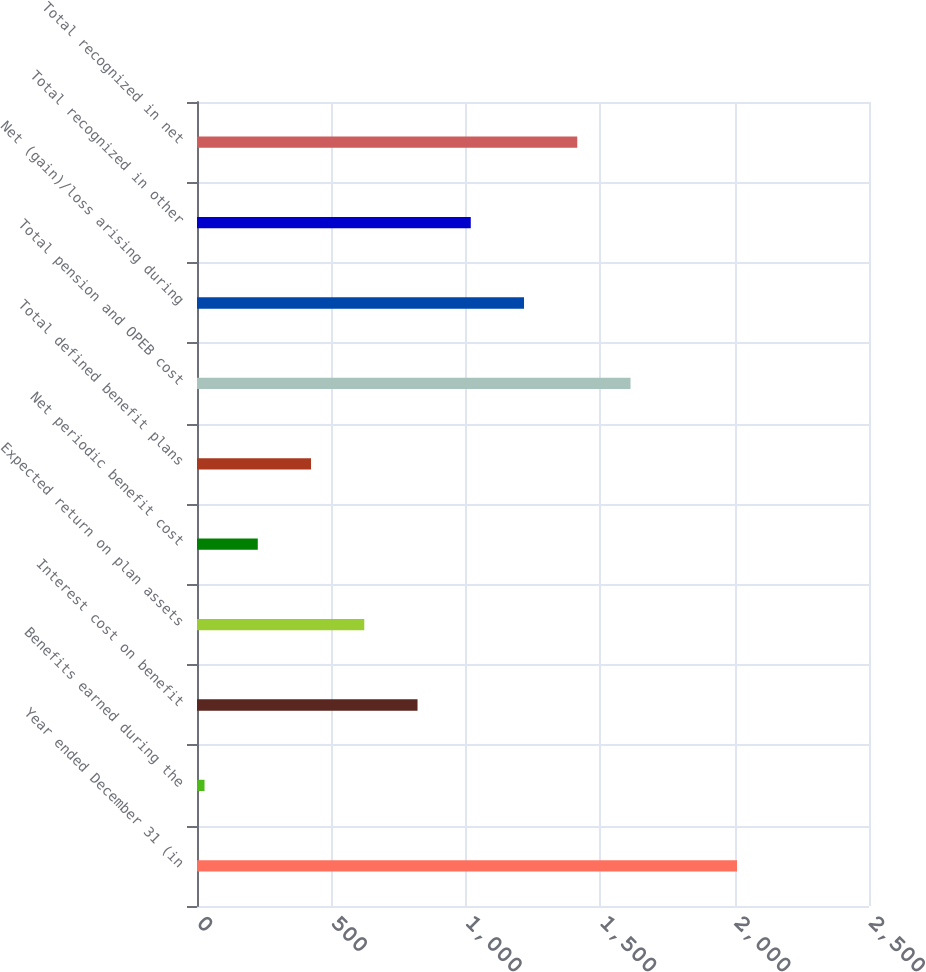Convert chart. <chart><loc_0><loc_0><loc_500><loc_500><bar_chart><fcel>Year ended December 31 (in<fcel>Benefits earned during the<fcel>Interest cost on benefit<fcel>Expected return on plan assets<fcel>Net periodic benefit cost<fcel>Total defined benefit plans<fcel>Total pension and OPEB cost<fcel>Net (gain)/loss arising during<fcel>Total recognized in other<fcel>Total recognized in net<nl><fcel>2009<fcel>28<fcel>820.4<fcel>622.3<fcel>226.1<fcel>424.2<fcel>1612.8<fcel>1216.6<fcel>1018.5<fcel>1414.7<nl></chart> 